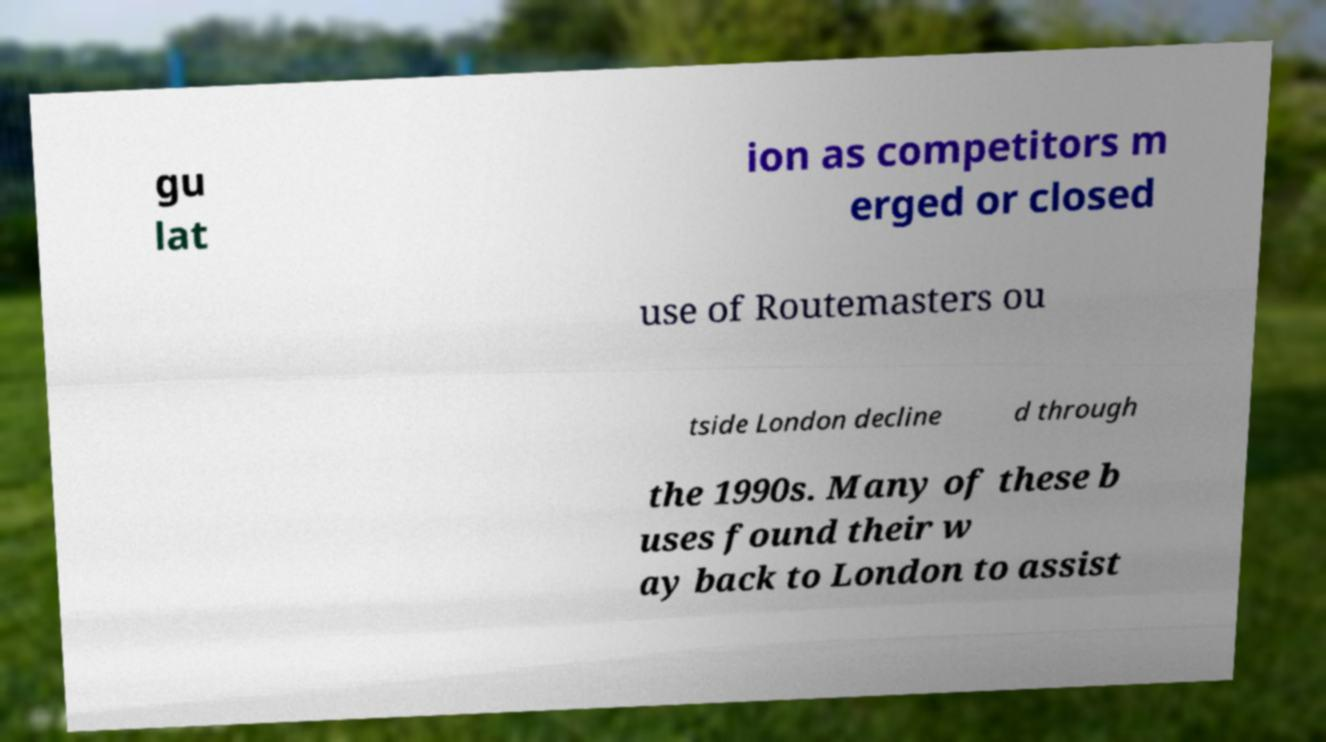Can you accurately transcribe the text from the provided image for me? gu lat ion as competitors m erged or closed use of Routemasters ou tside London decline d through the 1990s. Many of these b uses found their w ay back to London to assist 